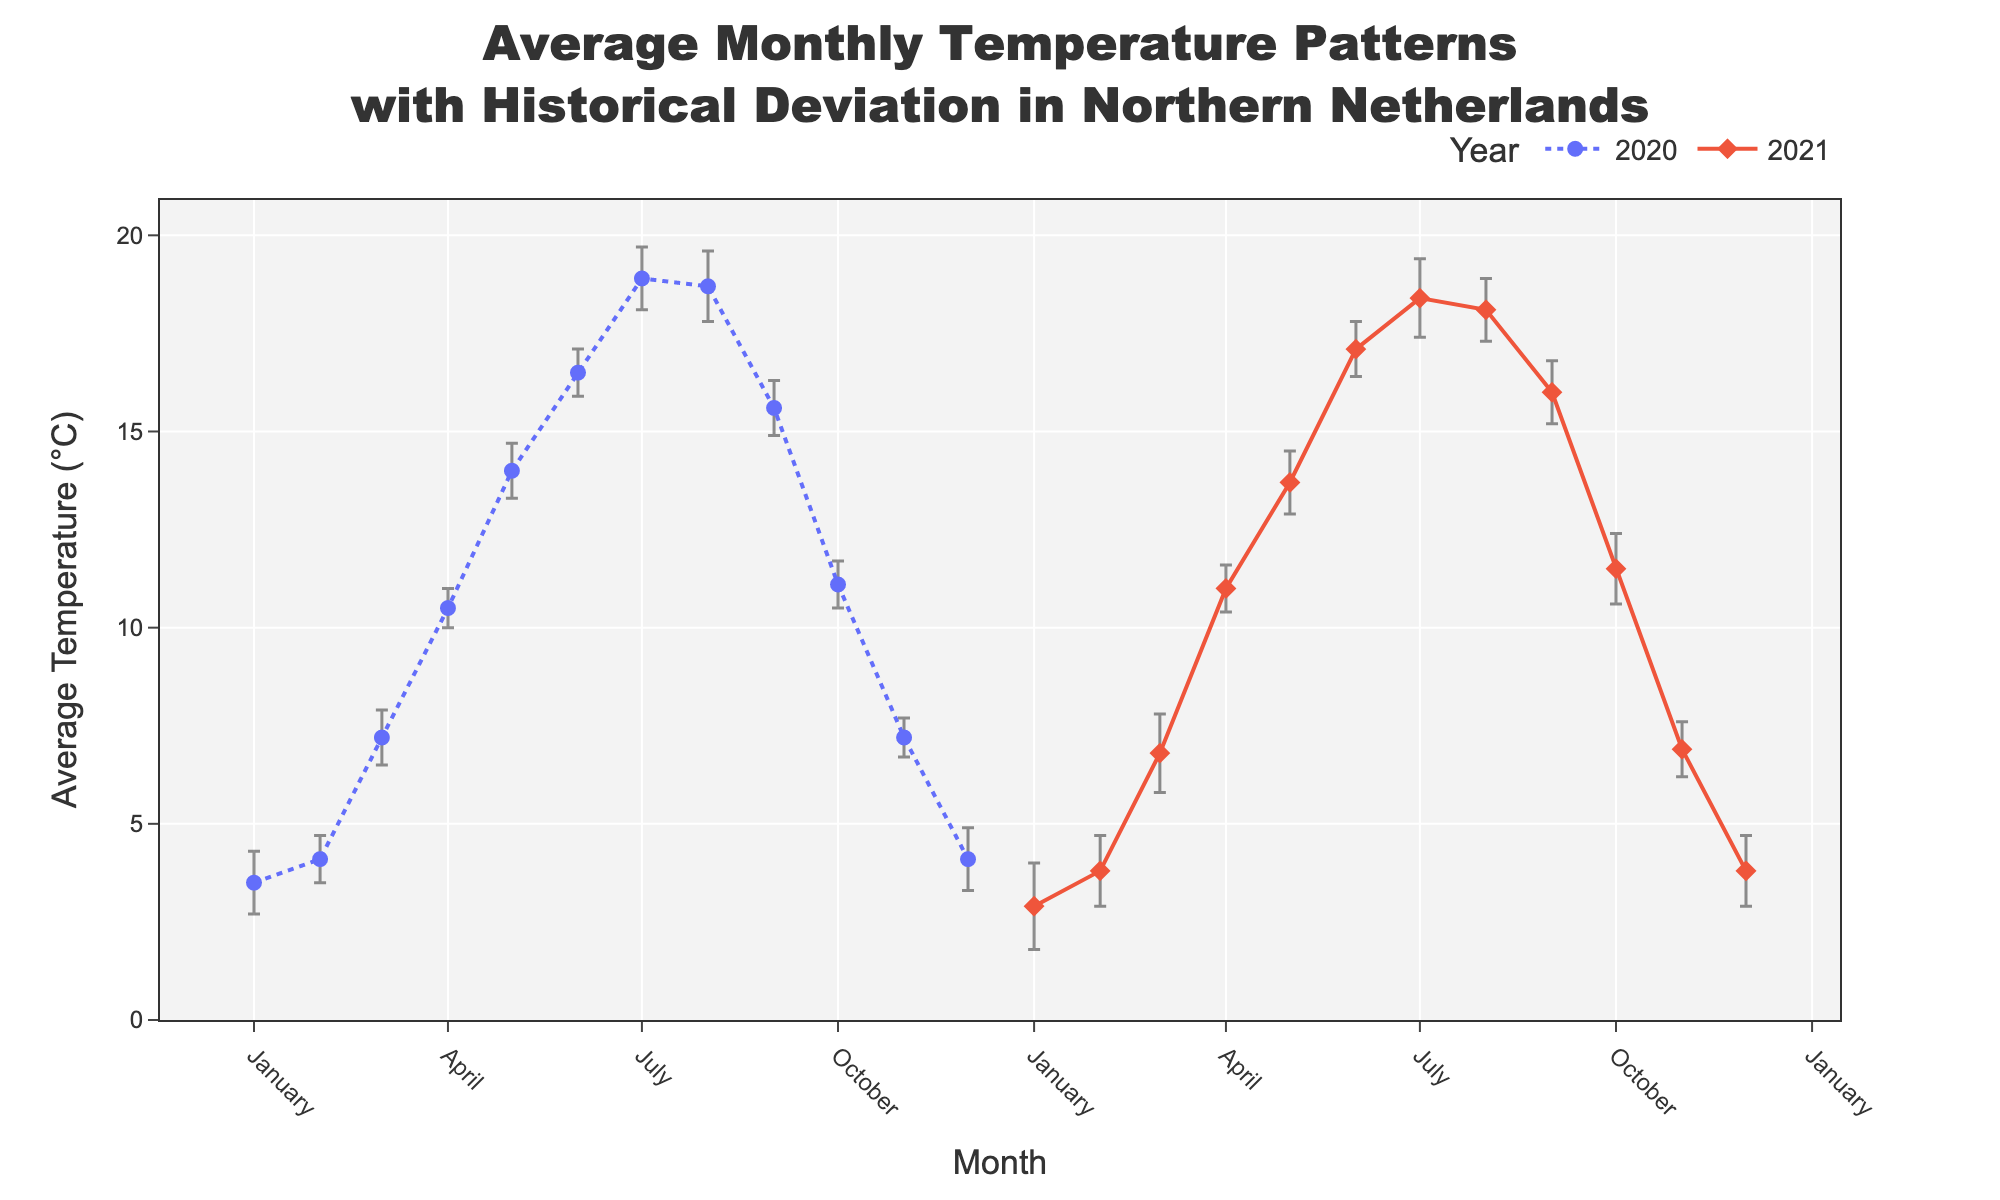What's the title of the plot? The title of the plot is given at the top, and it reads "Average Monthly Temperature Patterns with Historical Deviation in Northern Netherlands".
Answer: Average Monthly Temperature Patterns with Historical Deviation in Northern Netherlands What are the average temperatures in January 2021 and January 2020? January 2021's average temperature is marked on the chart next to its marker, as is January 2020's. These markers show values of 2.9°C (2021) and 3.5°C (2020) respectively.
Answer: 2.9°C and 3.5°C Which month has the highest average temperature in the entire dataset? By observing the lines for 2020 and 2021, the highest point corresponds to June 2021, which is 17.1°C, located near July's range in the plot.
Answer: June 2021 What is the difference in average temperature between May and June 2020? The value for May 2020 is 14.0°C and for June 2020 it is 16.5°C. Subtracting the two gives 16.5 - 14.0 = 2.5°C.
Answer: 2.5°C Which year had a higher average temperature in December, and by how much? December 2020 had an average temperature of 4.1°C, while December 2021 had an average of 3.8°C. The difference is 4.1 - 3.8 = 0.3°C.
Answer: 2020 by 0.3°C During which months in 2021 were average temperatures lower than in 2020? By checking corresponding months in 2020 and 2021, the months where 2021's average temperatures were lower include January, February, March, May, July, August, November, and December.
Answer: January, February, March, May, July, August, November, December Which month shows the smallest standard deviation in both years? Standard deviation values are indicated by the error bars. April 2020 has the smallest standard deviation at 0.5°C.
Answer: April 2020 Compare the standard deviation of average temperatures in July for both years. July 2020 has a standard deviation of 0.8°C, while July 2021 has a standard deviation of 1.0°C. Hence, July 2021's deviation is higher.
Answer: July 2021 What is the mean of the average temperatures for April in 2020 and 2021? Averaging April 2020 (10.5°C) and April 2021 (11.0°C): (10.5 + 11.0)/2 = 10.75°C.
Answer: 10.75°C Identify the months where the standard deviation is exactly the same for both years. Observe which months have equal error bars for 2020 and 2021. February, March, and September all show standard deviations of 0.6, 0.7, and 0.8°C, respectively.
Answer: February, March, September 